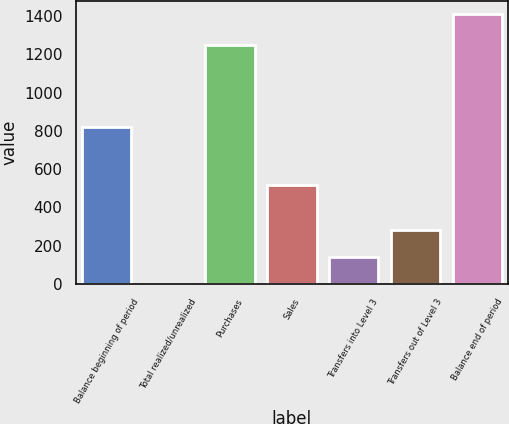<chart> <loc_0><loc_0><loc_500><loc_500><bar_chart><fcel>Balance beginning of period<fcel>Total realized/unrealized<fcel>Purchases<fcel>Sales<fcel>Transfers into Level 3<fcel>Transfers out of Level 3<fcel>Balance end of period<nl><fcel>822<fcel>2<fcel>1246<fcel>519<fcel>142.7<fcel>283.4<fcel>1409<nl></chart> 